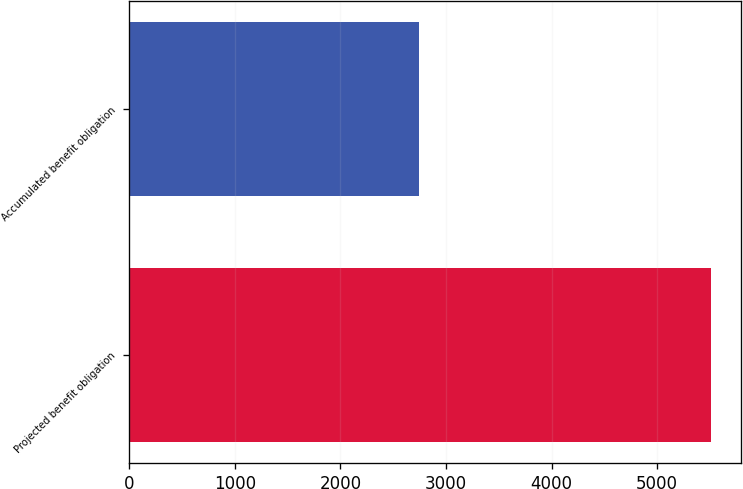Convert chart to OTSL. <chart><loc_0><loc_0><loc_500><loc_500><bar_chart><fcel>Projected benefit obligation<fcel>Accumulated benefit obligation<nl><fcel>5513<fcel>2749<nl></chart> 